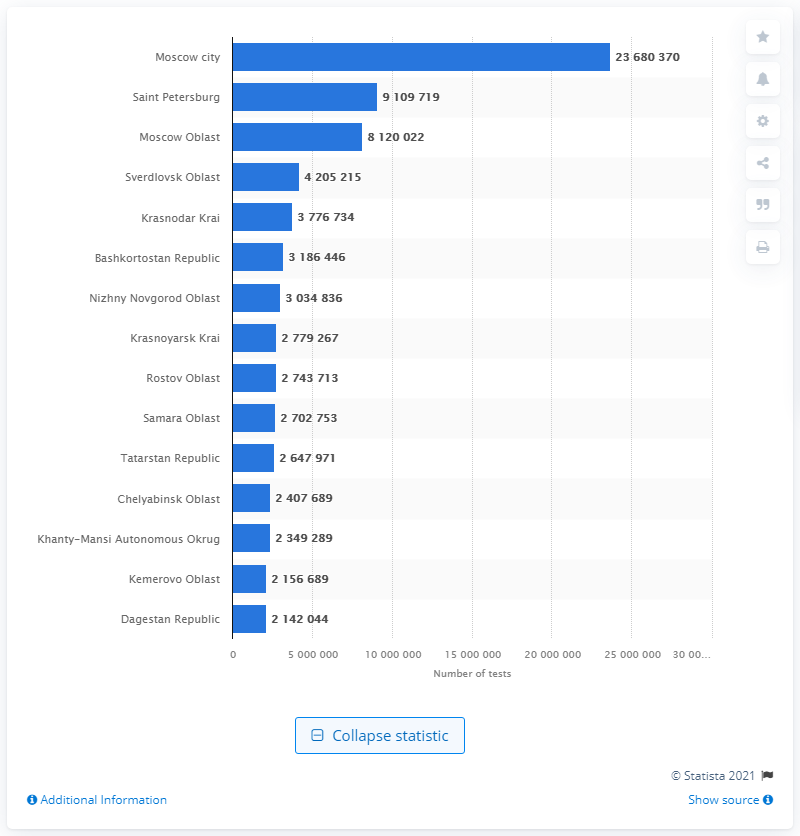Specify some key components in this picture. In Saint Petersburg, a total of 9,109,719 tests were recorded. 